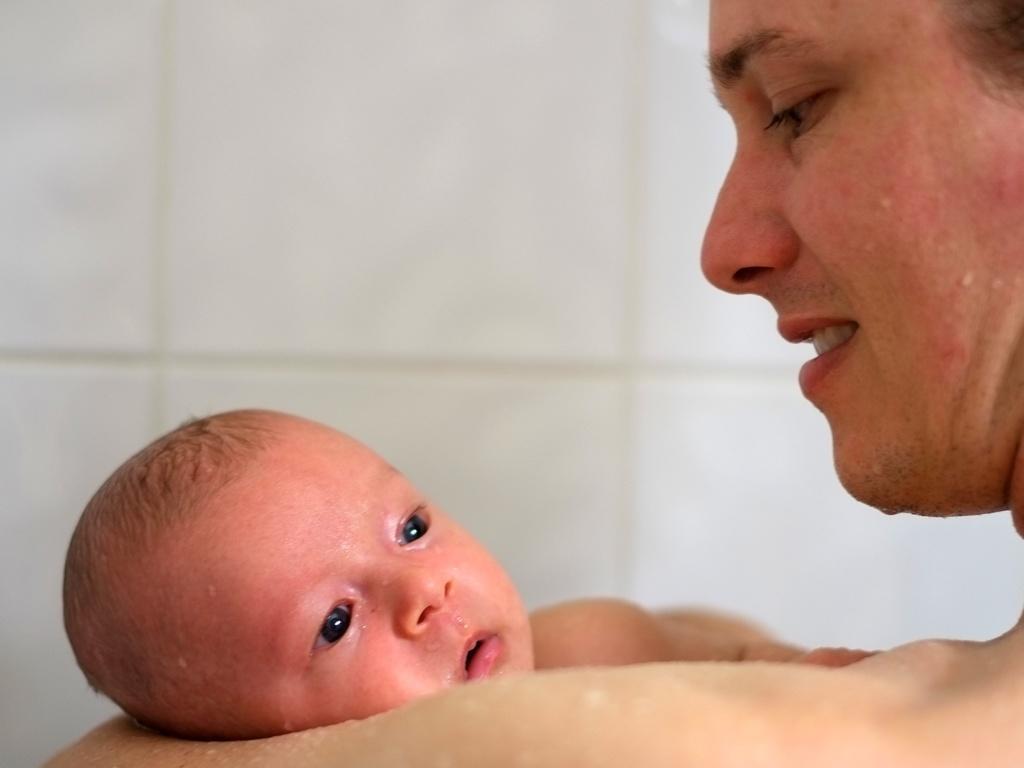Could you give a brief overview of what you see in this image? In the picture we can see a person holding a baby and to them we can see a water droplet and in the background, we can see a wall with tiles which are white in color. 